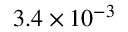<formula> <loc_0><loc_0><loc_500><loc_500>3 . 4 \times 1 0 ^ { - 3 }</formula> 